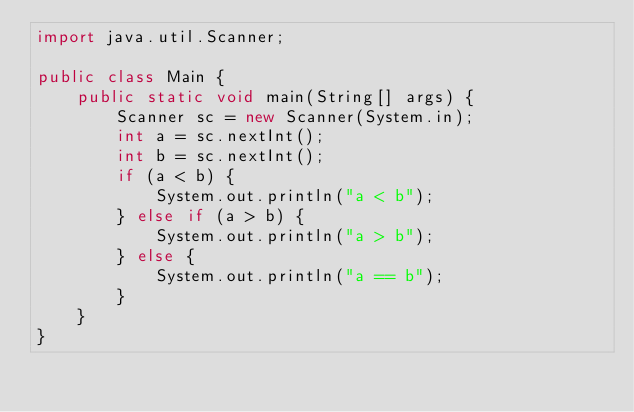Convert code to text. <code><loc_0><loc_0><loc_500><loc_500><_Java_>import java.util.Scanner;

public class Main {
	public static void main(String[] args) {
		Scanner sc = new Scanner(System.in);
		int a = sc.nextInt();
		int b = sc.nextInt();
		if (a < b) {
			System.out.println("a < b");
		} else if (a > b) {
			System.out.println("a > b");
		} else {
			System.out.println("a == b");
		}
	}
}</code> 